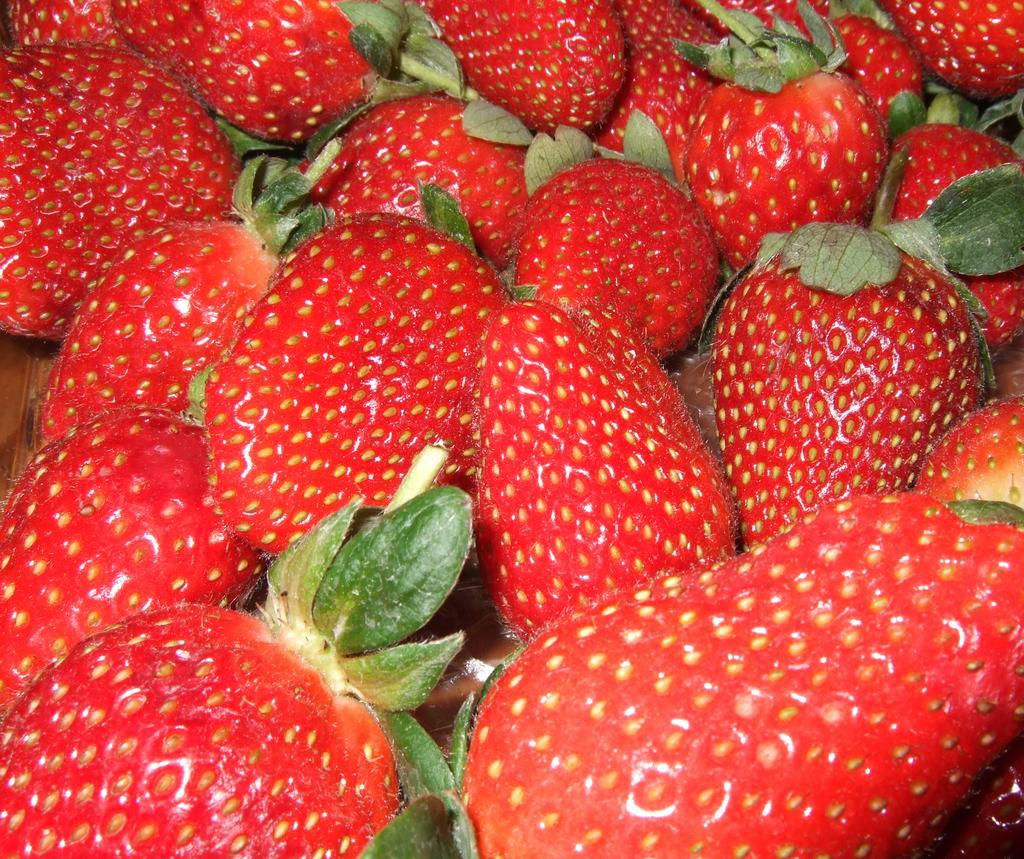What type of fruit is present in the image? There are strawberries in the image. What is the color of the strawberries? The strawberries are red in color. What other colors can be seen on the strawberries? The strawberries have brown and green parts. On what surface are the strawberries placed? The strawberries are on a brown colored surface. What type of reward does the daughter receive for using the swing in the image? There is no swing or daughter present in the image, and therefore no reward can be given for using a swing. 